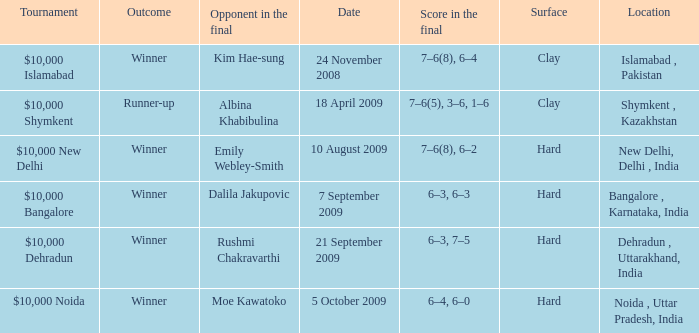What is the date of the game played in the bangalore , karnataka, india location 7 September 2009. 